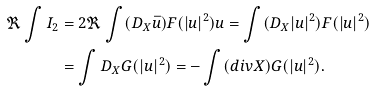<formula> <loc_0><loc_0><loc_500><loc_500>\Re \int I _ { 2 } & = 2 \Re \int ( D _ { X } \bar { u } ) F ( | u | ^ { 2 } ) u = \int ( D _ { X } | u | ^ { 2 } ) F ( | u | ^ { 2 } ) \\ & = \int D _ { X } G ( | u | ^ { 2 } ) = - \int ( d i v { X } ) G ( | u | ^ { 2 } ) .</formula> 